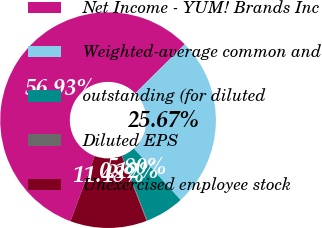<chart> <loc_0><loc_0><loc_500><loc_500><pie_chart><fcel>Net Income - YUM! Brands Inc<fcel>Weighted-average common and<fcel>outstanding (for diluted<fcel>Diluted EPS<fcel>Unexercised employee stock<nl><fcel>56.93%<fcel>25.67%<fcel>5.8%<fcel>0.12%<fcel>11.48%<nl></chart> 